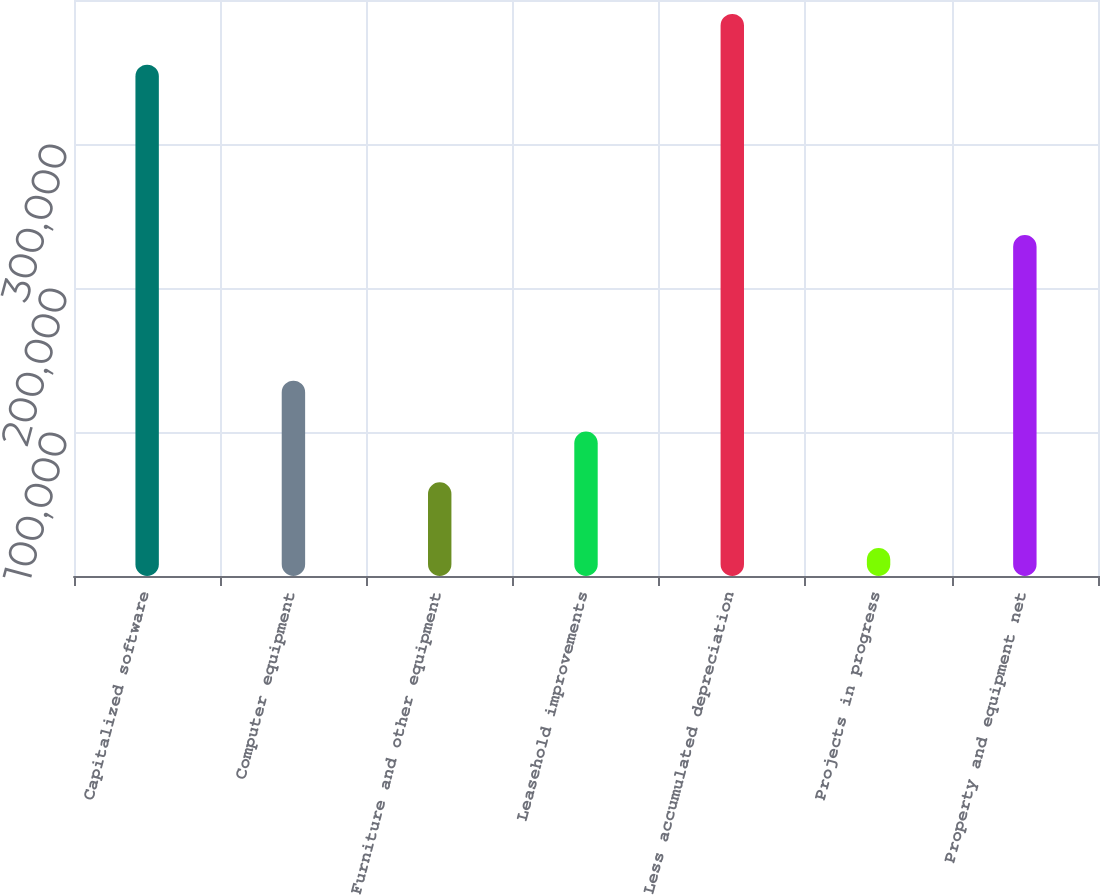Convert chart. <chart><loc_0><loc_0><loc_500><loc_500><bar_chart><fcel>Capitalized software<fcel>Computer equipment<fcel>Furniture and other equipment<fcel>Leasehold improvements<fcel>Less accumulated depreciation<fcel>Projects in progress<fcel>Property and equipment net<nl><fcel>355088<fcel>135628<fcel>65098<fcel>100363<fcel>390353<fcel>19401<fcel>236820<nl></chart> 